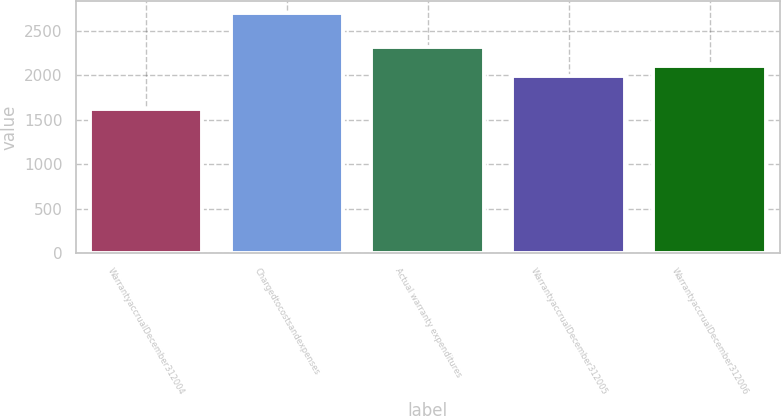<chart> <loc_0><loc_0><loc_500><loc_500><bar_chart><fcel>WarrantyaccrualDecember312004<fcel>Chargedtocostsandexpenses<fcel>Actual warranty expenditures<fcel>WarrantyaccrualDecember312005<fcel>WarrantyaccrualDecember312006<nl><fcel>1616<fcel>2699<fcel>2317<fcel>1998<fcel>2106.3<nl></chart> 